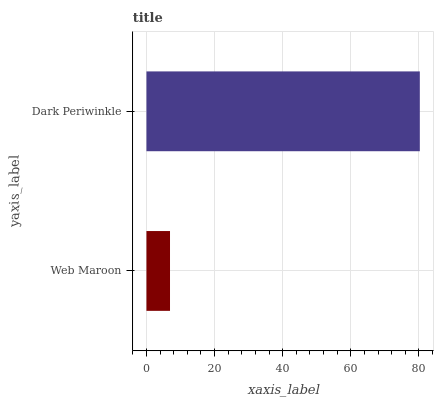Is Web Maroon the minimum?
Answer yes or no. Yes. Is Dark Periwinkle the maximum?
Answer yes or no. Yes. Is Dark Periwinkle the minimum?
Answer yes or no. No. Is Dark Periwinkle greater than Web Maroon?
Answer yes or no. Yes. Is Web Maroon less than Dark Periwinkle?
Answer yes or no. Yes. Is Web Maroon greater than Dark Periwinkle?
Answer yes or no. No. Is Dark Periwinkle less than Web Maroon?
Answer yes or no. No. Is Dark Periwinkle the high median?
Answer yes or no. Yes. Is Web Maroon the low median?
Answer yes or no. Yes. Is Web Maroon the high median?
Answer yes or no. No. Is Dark Periwinkle the low median?
Answer yes or no. No. 